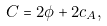Convert formula to latex. <formula><loc_0><loc_0><loc_500><loc_500>C = 2 \phi + 2 c _ { A } ,</formula> 